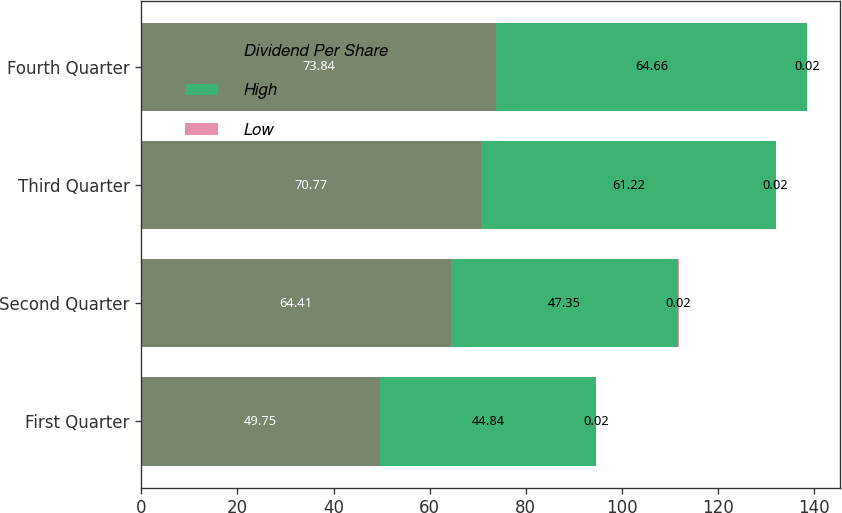Convert chart to OTSL. <chart><loc_0><loc_0><loc_500><loc_500><stacked_bar_chart><ecel><fcel>First Quarter<fcel>Second Quarter<fcel>Third Quarter<fcel>Fourth Quarter<nl><fcel>Dividend Per Share<fcel>49.75<fcel>64.41<fcel>70.77<fcel>73.84<nl><fcel>High<fcel>44.84<fcel>47.35<fcel>61.22<fcel>64.66<nl><fcel>Low<fcel>0.02<fcel>0.02<fcel>0.02<fcel>0.02<nl></chart> 